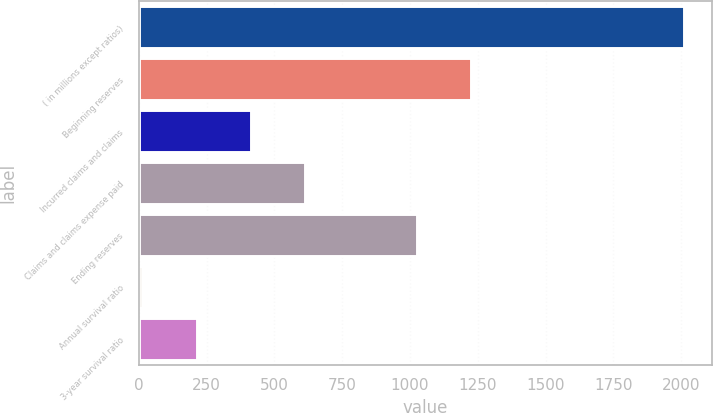<chart> <loc_0><loc_0><loc_500><loc_500><bar_chart><fcel>( in millions except ratios)<fcel>Beginning reserves<fcel>Incurred claims and claims<fcel>Claims and claims expense paid<fcel>Ending reserves<fcel>Annual survival ratio<fcel>3-year survival ratio<nl><fcel>2012<fcel>1225.88<fcel>412.96<fcel>612.84<fcel>1026<fcel>13.2<fcel>213.08<nl></chart> 